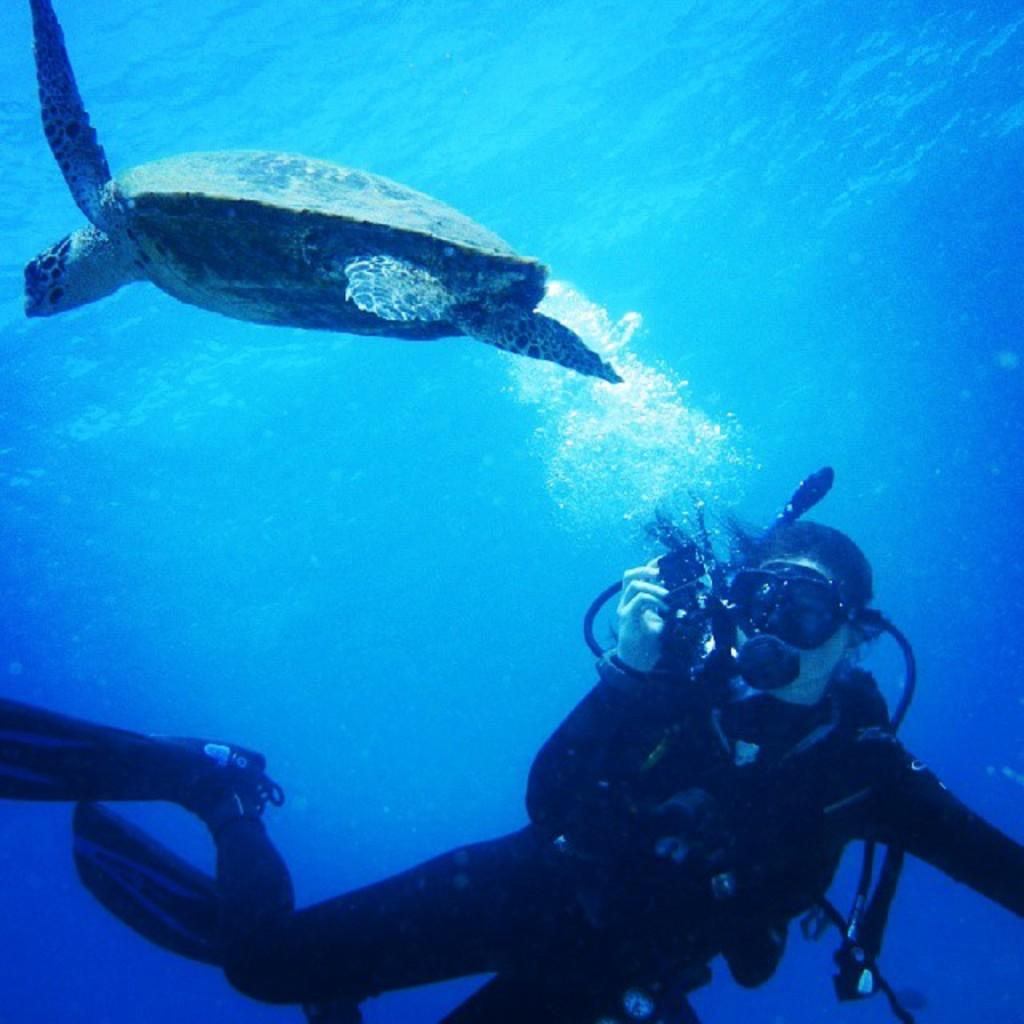What type of animal is in the image? There is a fish in the image. Who or what else is present in the image? There is a person in the image. What is the primary element in which the fish is situated? There is water visible in the image, and the fish is likely in the water. What type of apples can be seen floating in the water in the image? There are no apples present in the image; it features a fish and a person in water. How is the glue being used in the image? There is no glue present in the image. 